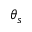Convert formula to latex. <formula><loc_0><loc_0><loc_500><loc_500>\theta _ { s }</formula> 